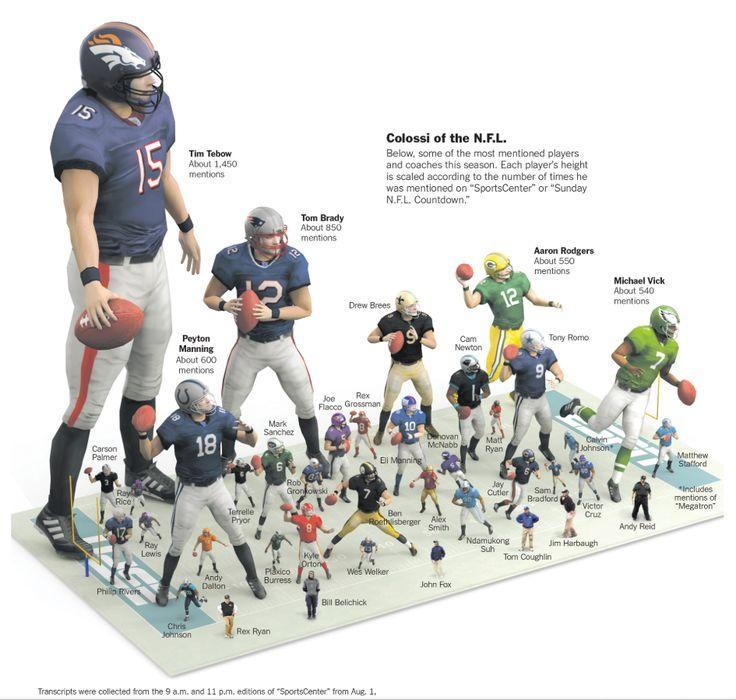How many mentions came for the player in Jersey Number 12 on Sports Center Countdown?
Answer the question with a short phrase. about 550 mentions What is the name of the player in Green Jersey number 7? Michael Vick Which player got the second-highest no of mentions on Sports Center Countdown? Tom Brady Which player got the third-highest no of mentions on Sports Center Countdown? Peyton Manning What is the Jersey number of the player Michael Vick? 7 